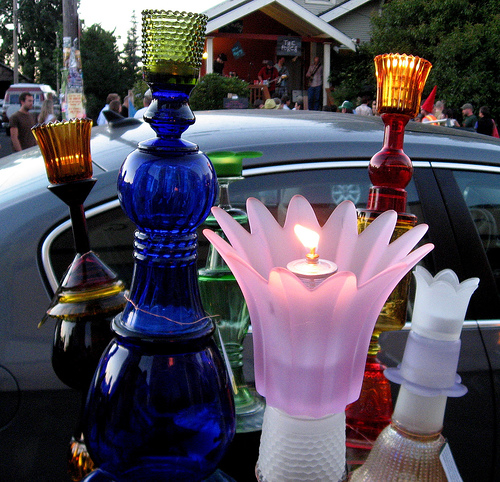<image>
Is there a man in front of the car? No. The man is not in front of the car. The spatial positioning shows a different relationship between these objects. 